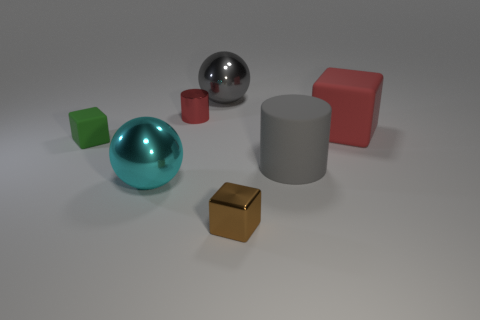Is the color of the large shiny object behind the red block the same as the cylinder to the right of the brown thing?
Offer a terse response. Yes. Are there fewer cyan metal things than purple shiny spheres?
Provide a short and direct response. No. What shape is the big metallic thing left of the ball that is right of the shiny cylinder?
Ensure brevity in your answer.  Sphere. What shape is the red metal thing that is the same size as the brown block?
Keep it short and to the point. Cylinder. Is there another object that has the same shape as the brown metallic thing?
Ensure brevity in your answer.  Yes. What is the brown object made of?
Offer a very short reply. Metal. Are there any big cyan things in front of the gray matte thing?
Your response must be concise. Yes. What number of big rubber objects are right of the cylinder that is right of the brown metallic object?
Your answer should be very brief. 1. There is a red object that is the same size as the gray sphere; what is its material?
Provide a succinct answer. Rubber. How many other things are there of the same material as the large red cube?
Your answer should be very brief. 2. 